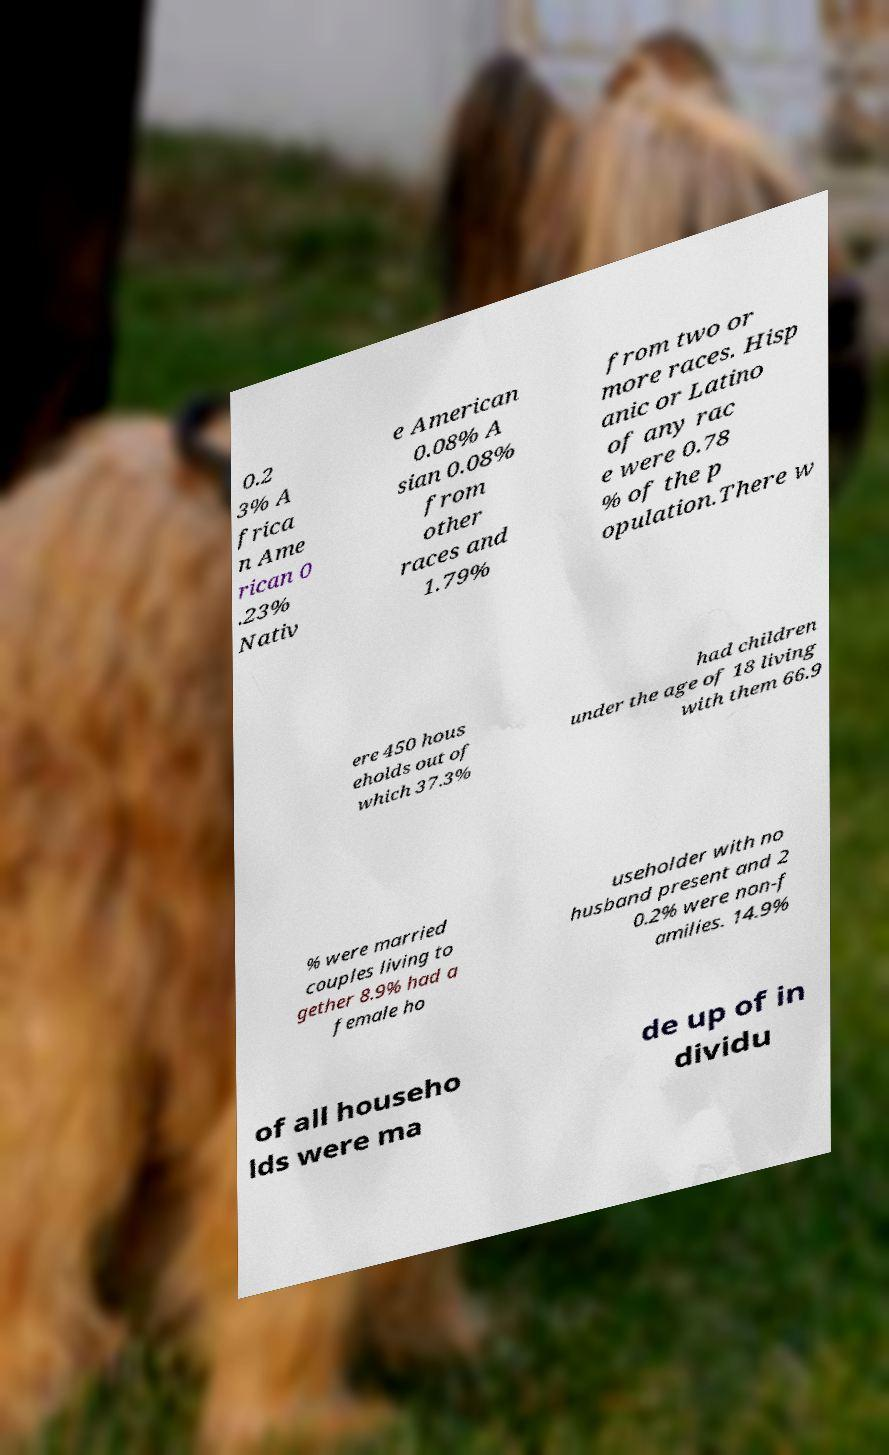Can you read and provide the text displayed in the image?This photo seems to have some interesting text. Can you extract and type it out for me? 0.2 3% A frica n Ame rican 0 .23% Nativ e American 0.08% A sian 0.08% from other races and 1.79% from two or more races. Hisp anic or Latino of any rac e were 0.78 % of the p opulation.There w ere 450 hous eholds out of which 37.3% had children under the age of 18 living with them 66.9 % were married couples living to gether 8.9% had a female ho useholder with no husband present and 2 0.2% were non-f amilies. 14.9% of all househo lds were ma de up of in dividu 